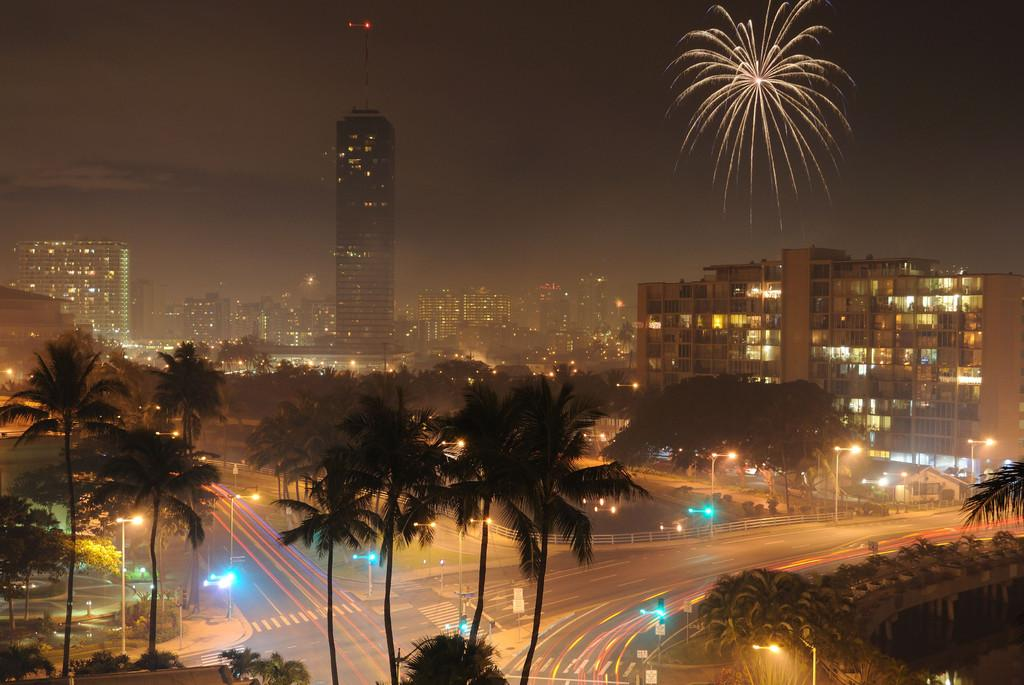What type of structures are visible in the image? There is a group of buildings with windows in the image. Are there any lights visible on the buildings? Yes, some lights are visible on the buildings. What type of infrastructure can be seen in the image? There are roads and poles present in the image. What type of illumination is provided along the roads? Street lamps are visible in the image. What natural element is visible in the image? There is water visible in the image. What type of vegetation is present in the image? A group of trees is present in the image. What type of event is taking place in the image? Fireworks are visible in the sky. Where is the notebook located in the image? There is no notebook present in the image. What type of fowl can be seen in the image? There is no fowl present in the image. 